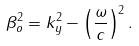Convert formula to latex. <formula><loc_0><loc_0><loc_500><loc_500>\beta _ { o } ^ { 2 } = k _ { y } ^ { 2 } - \left ( \frac { \omega } { c } \right ) ^ { 2 } .</formula> 